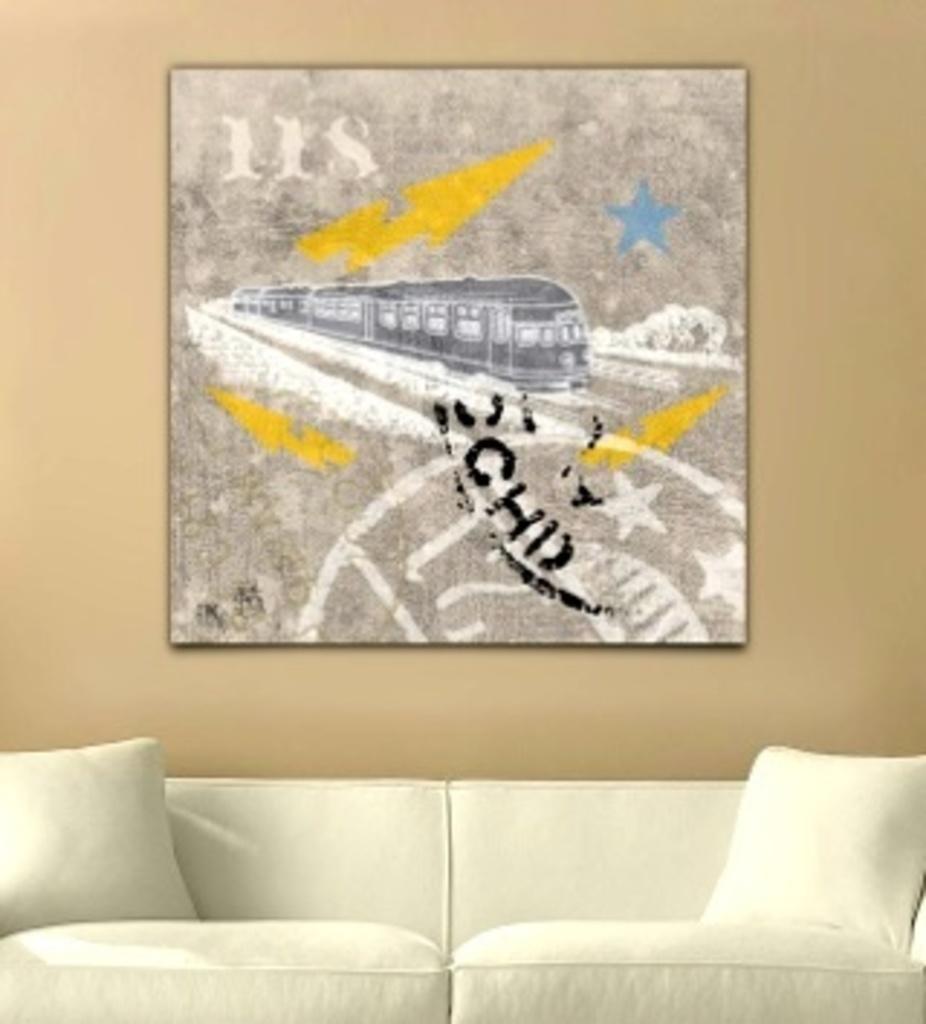Could you give a brief overview of what you see in this image? This picture is clicked inside the room. On the bottom of the picture, we see a sofa which is white in color and two pillows. Behind that, we see a wall in cream color and on wall, we see a photo frame in which we see train. 